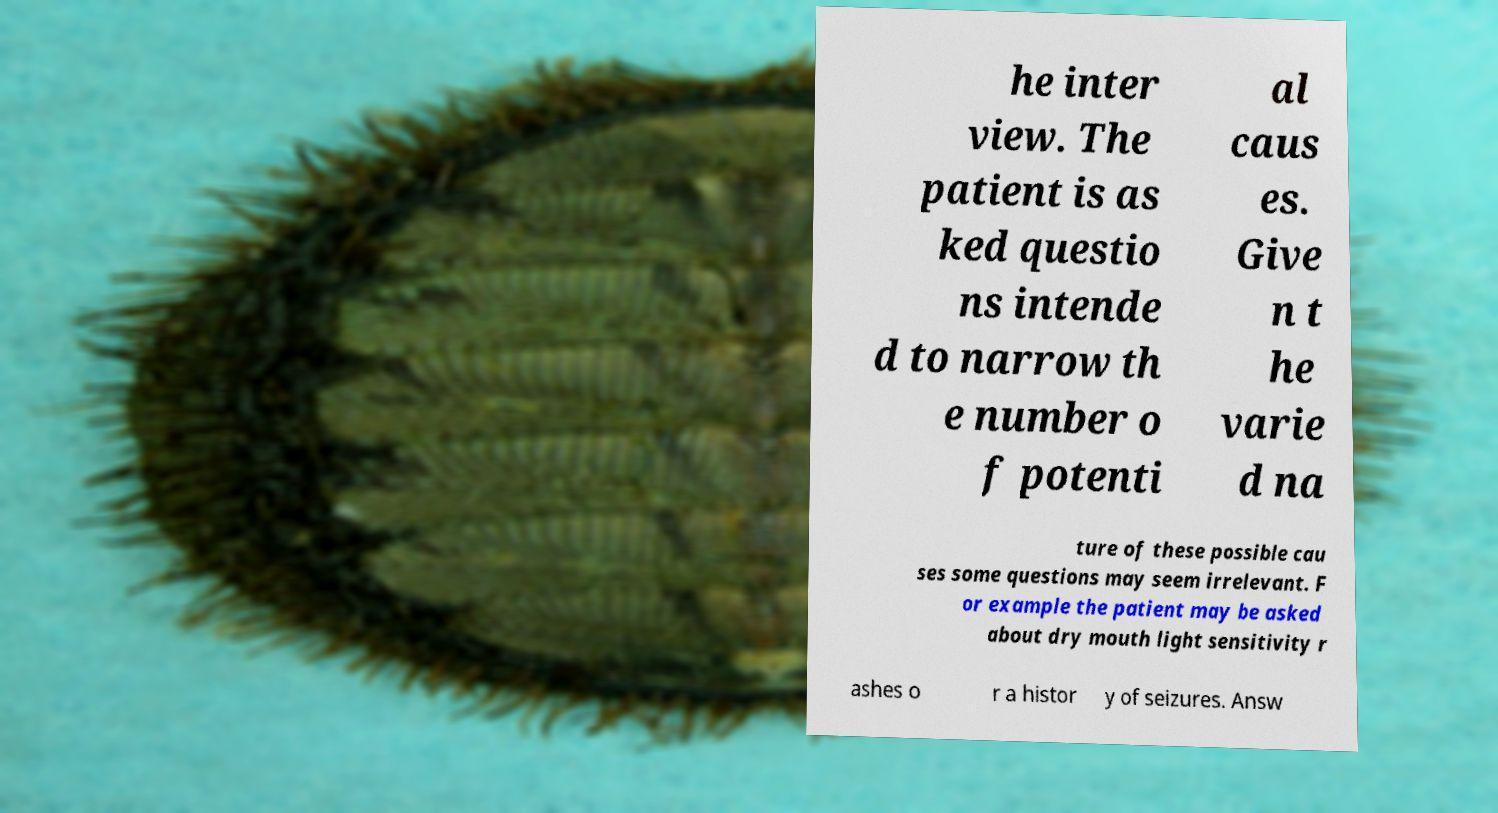For documentation purposes, I need the text within this image transcribed. Could you provide that? he inter view. The patient is as ked questio ns intende d to narrow th e number o f potenti al caus es. Give n t he varie d na ture of these possible cau ses some questions may seem irrelevant. F or example the patient may be asked about dry mouth light sensitivity r ashes o r a histor y of seizures. Answ 